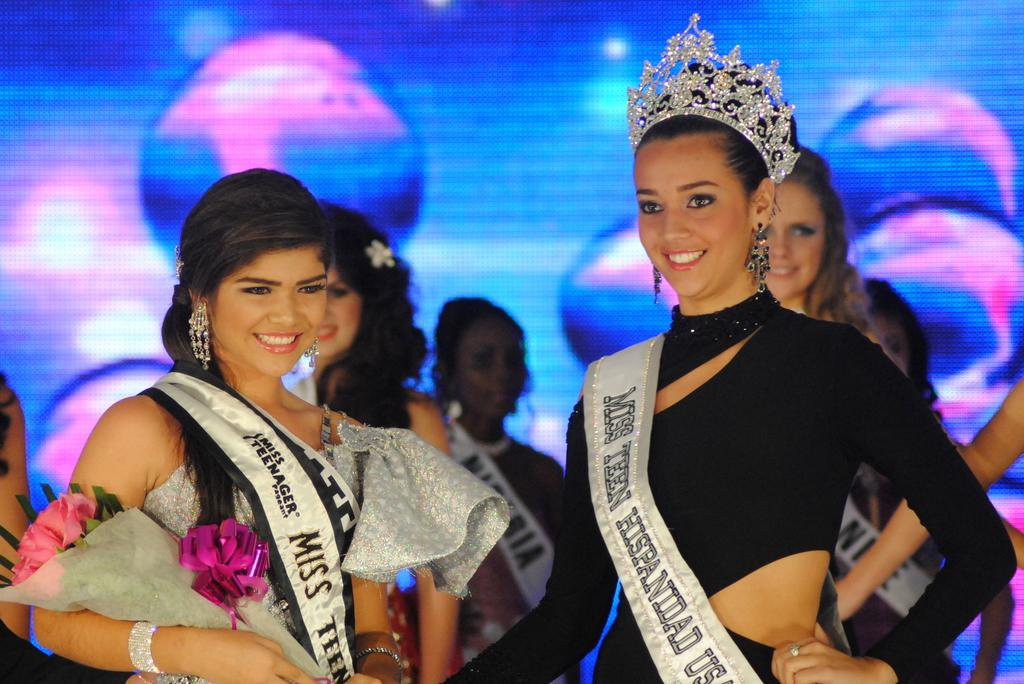<image>
Give a short and clear explanation of the subsequent image. Two women stand in a beauty contest for Miss Teen Hispanidad. 